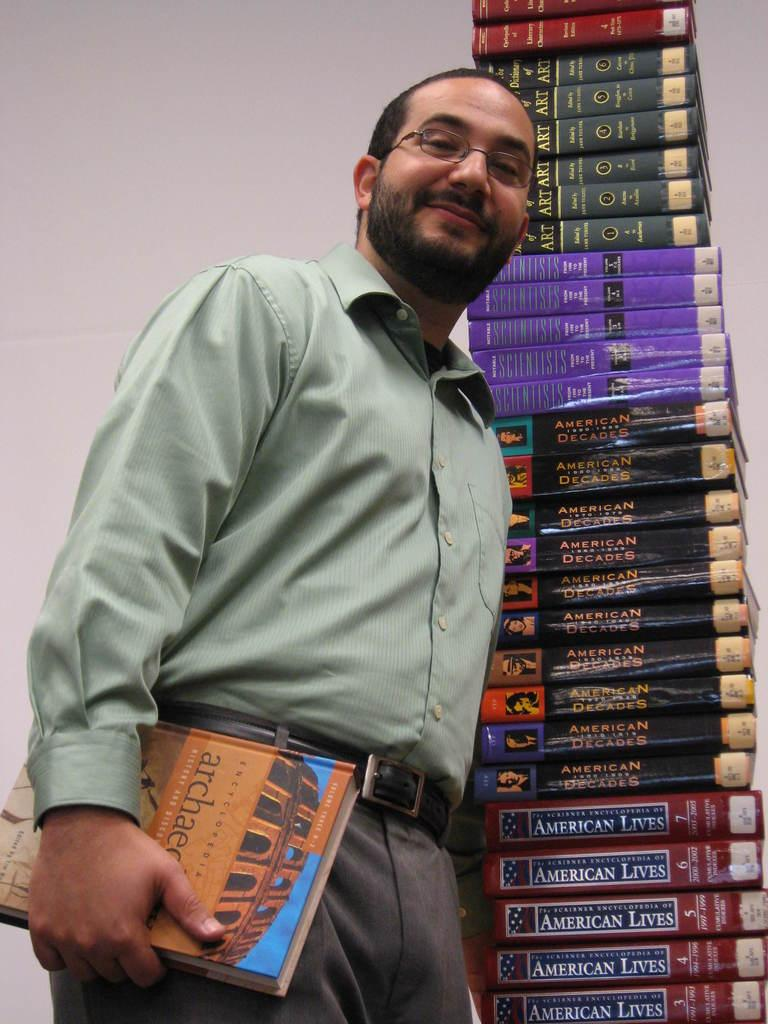<image>
Create a compact narrative representing the image presented. A smiling man holds a book on architecture while he stands next to a tall pile of textbooks. 